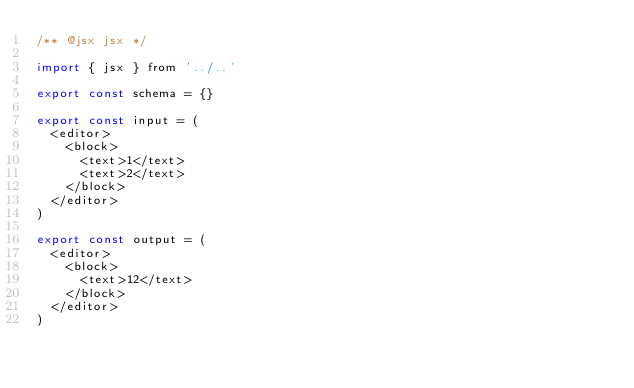Convert code to text. <code><loc_0><loc_0><loc_500><loc_500><_JavaScript_>/** @jsx jsx */

import { jsx } from '../..'

export const schema = {}

export const input = (
  <editor>
    <block>
      <text>1</text>
      <text>2</text>
    </block>
  </editor>
)

export const output = (
  <editor>
    <block>
      <text>12</text>
    </block>
  </editor>
)
</code> 